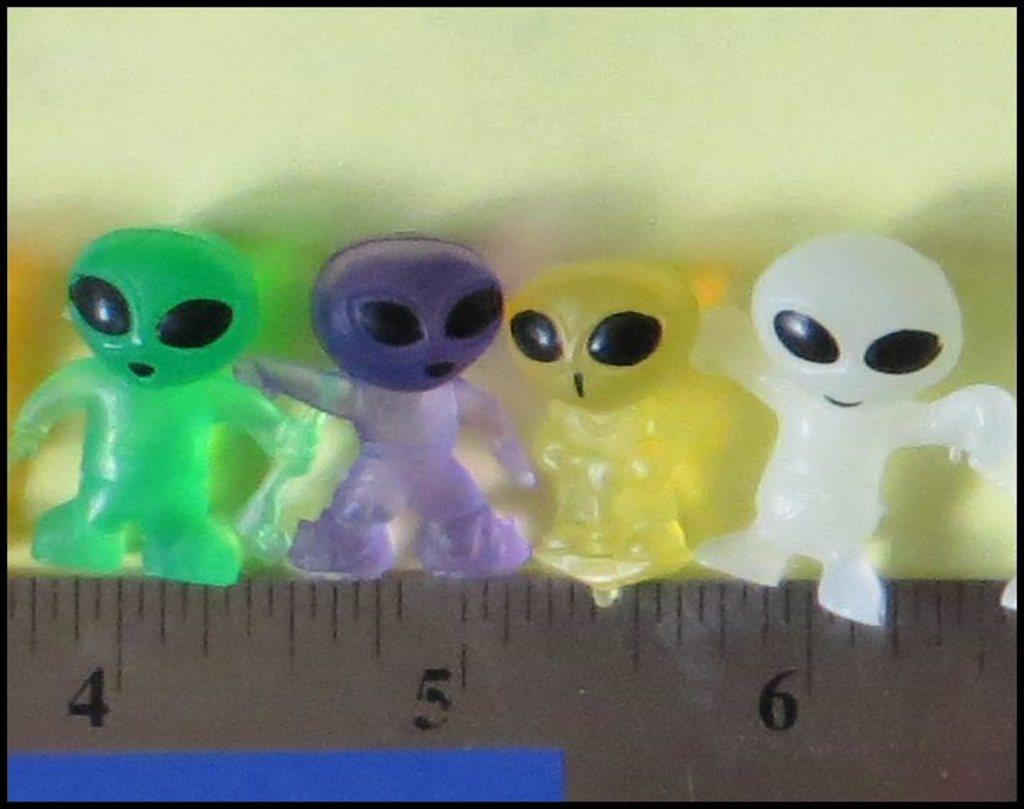What objects are placed on the scale in the image? There are toys placed on a scale in the image. What can be seen in the background of the image? There is a wall visible in the image. What type of stick is being used to measure the lettuce in the image? There is no stick or lettuce present in the image; it features toys placed on a scale and a visible wall. How many teeth can be seen in the image? There are no teeth visible in the image. 